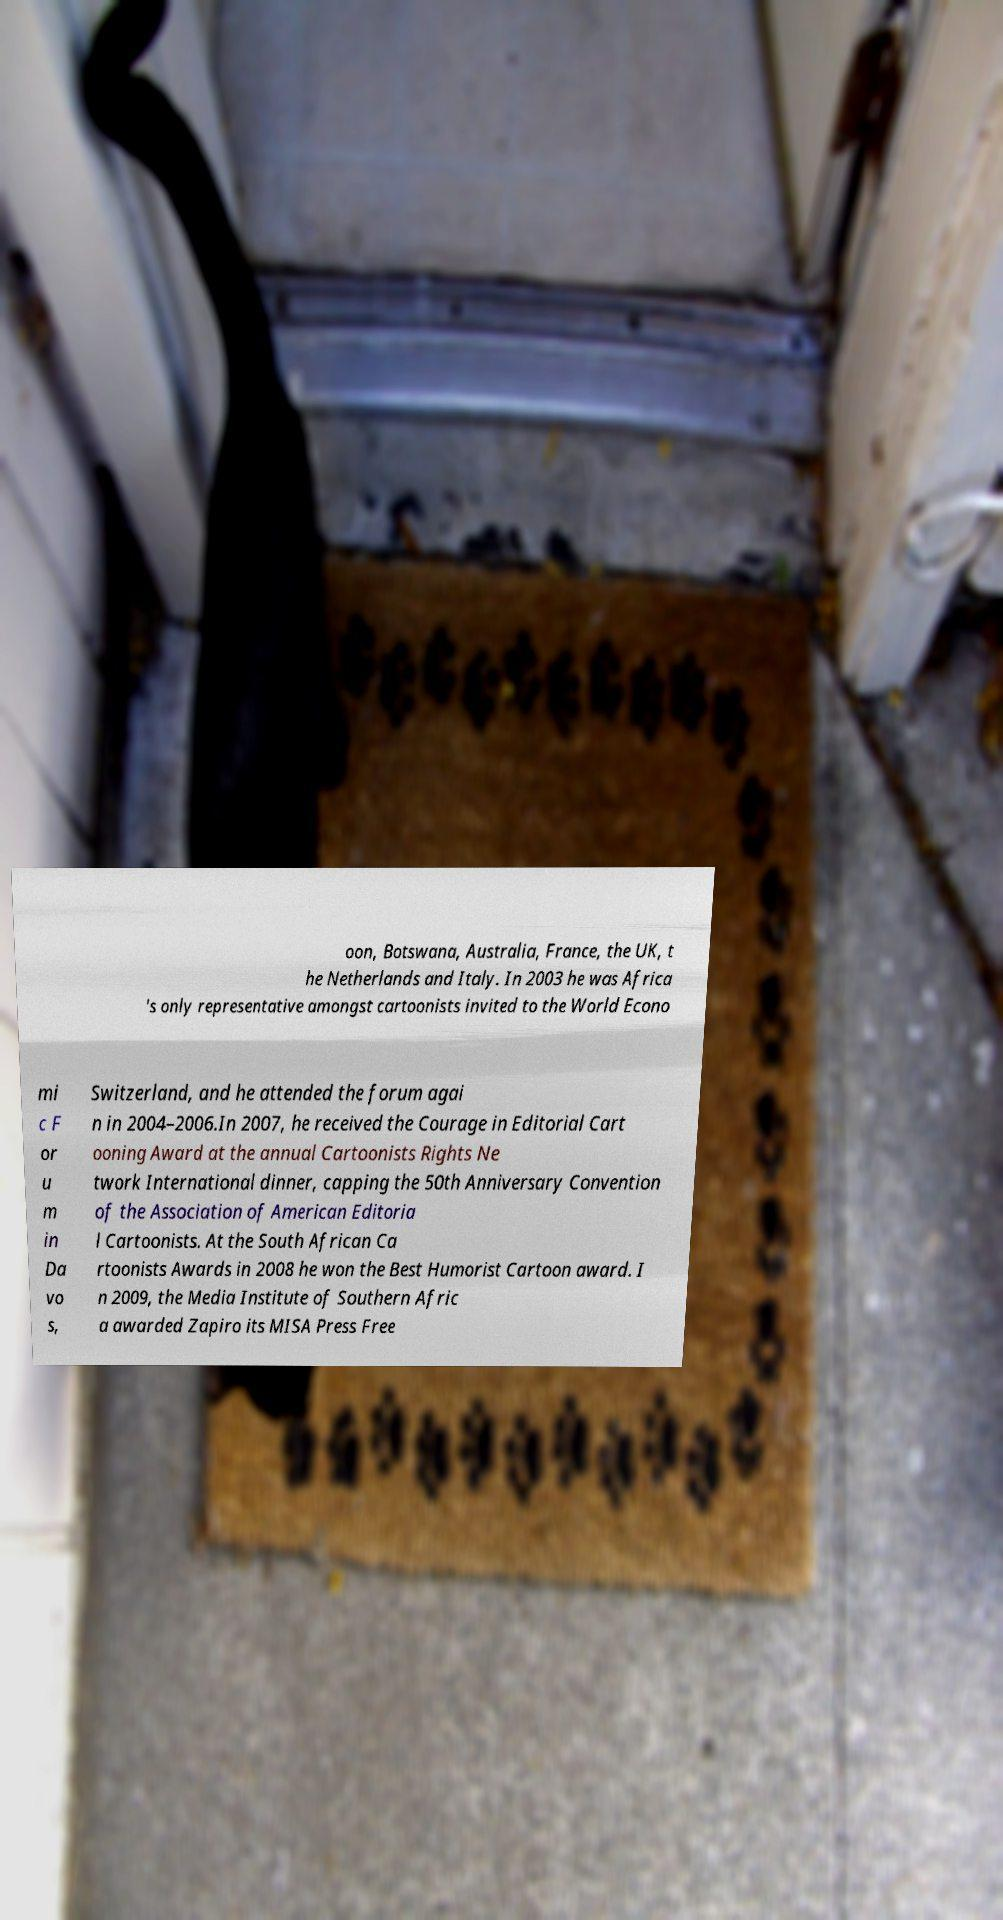Could you extract and type out the text from this image? oon, Botswana, Australia, France, the UK, t he Netherlands and Italy. In 2003 he was Africa 's only representative amongst cartoonists invited to the World Econo mi c F or u m in Da vo s, Switzerland, and he attended the forum agai n in 2004–2006.In 2007, he received the Courage in Editorial Cart ooning Award at the annual Cartoonists Rights Ne twork International dinner, capping the 50th Anniversary Convention of the Association of American Editoria l Cartoonists. At the South African Ca rtoonists Awards in 2008 he won the Best Humorist Cartoon award. I n 2009, the Media Institute of Southern Afric a awarded Zapiro its MISA Press Free 